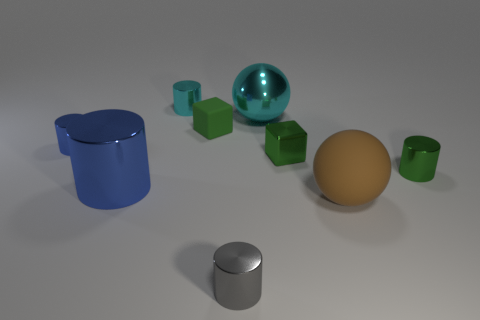Subtract all cyan cylinders. How many cylinders are left? 4 Subtract all large cylinders. How many cylinders are left? 4 Subtract all spheres. How many objects are left? 7 Subtract 1 spheres. How many spheres are left? 1 Subtract 0 cyan cubes. How many objects are left? 9 Subtract all gray cylinders. Subtract all green spheres. How many cylinders are left? 4 Subtract all red balls. How many blue cylinders are left? 2 Subtract all large objects. Subtract all large brown objects. How many objects are left? 5 Add 2 cyan objects. How many cyan objects are left? 4 Add 8 big green shiny cubes. How many big green shiny cubes exist? 8 